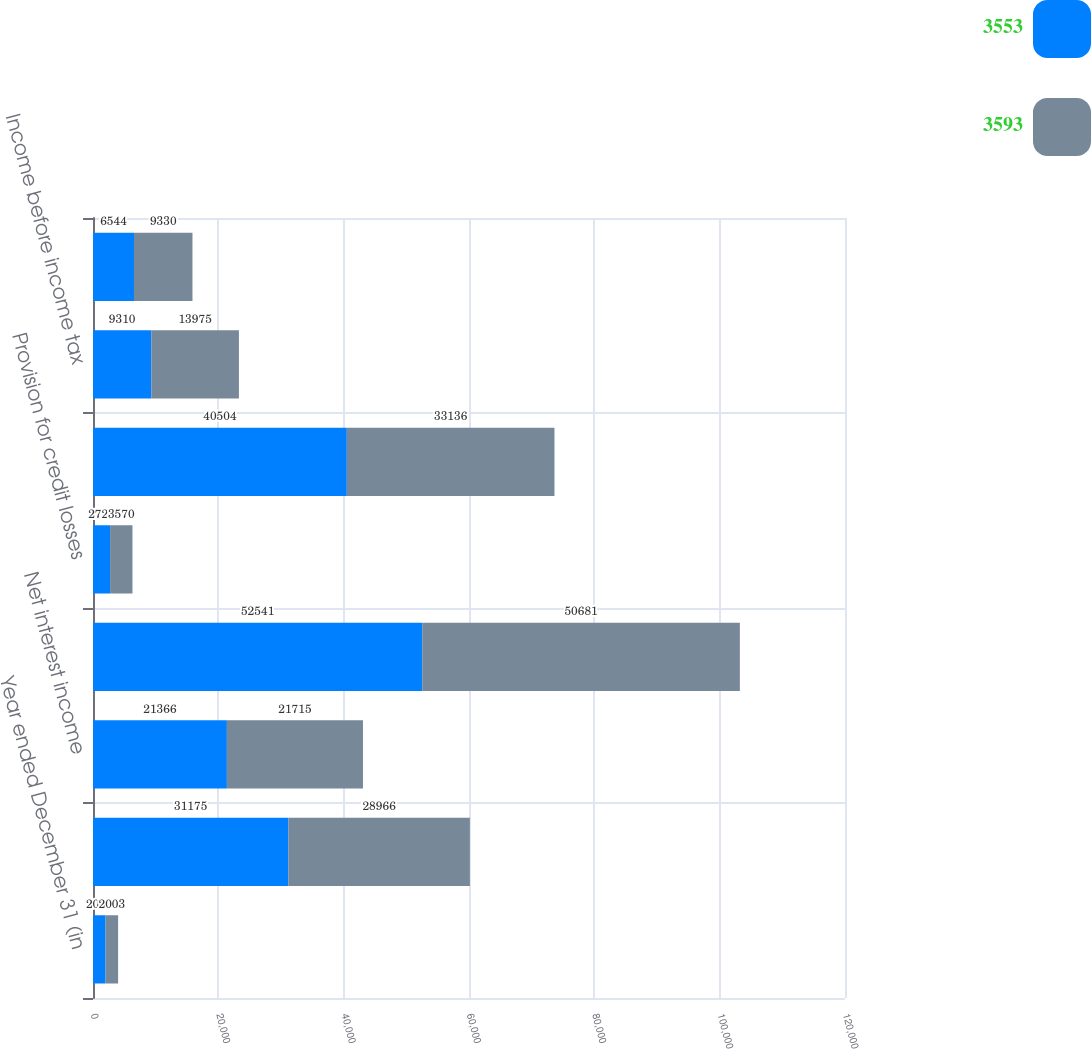<chart> <loc_0><loc_0><loc_500><loc_500><stacked_bar_chart><ecel><fcel>Year ended December 31 (in<fcel>Noninterest revenue<fcel>Net interest income<fcel>Total net revenue<fcel>Provision for credit losses<fcel>Noninterest expense<fcel>Income before income tax<fcel>Net income<nl><fcel>3553<fcel>2004<fcel>31175<fcel>21366<fcel>52541<fcel>2727<fcel>40504<fcel>9310<fcel>6544<nl><fcel>3593<fcel>2003<fcel>28966<fcel>21715<fcel>50681<fcel>3570<fcel>33136<fcel>13975<fcel>9330<nl></chart> 